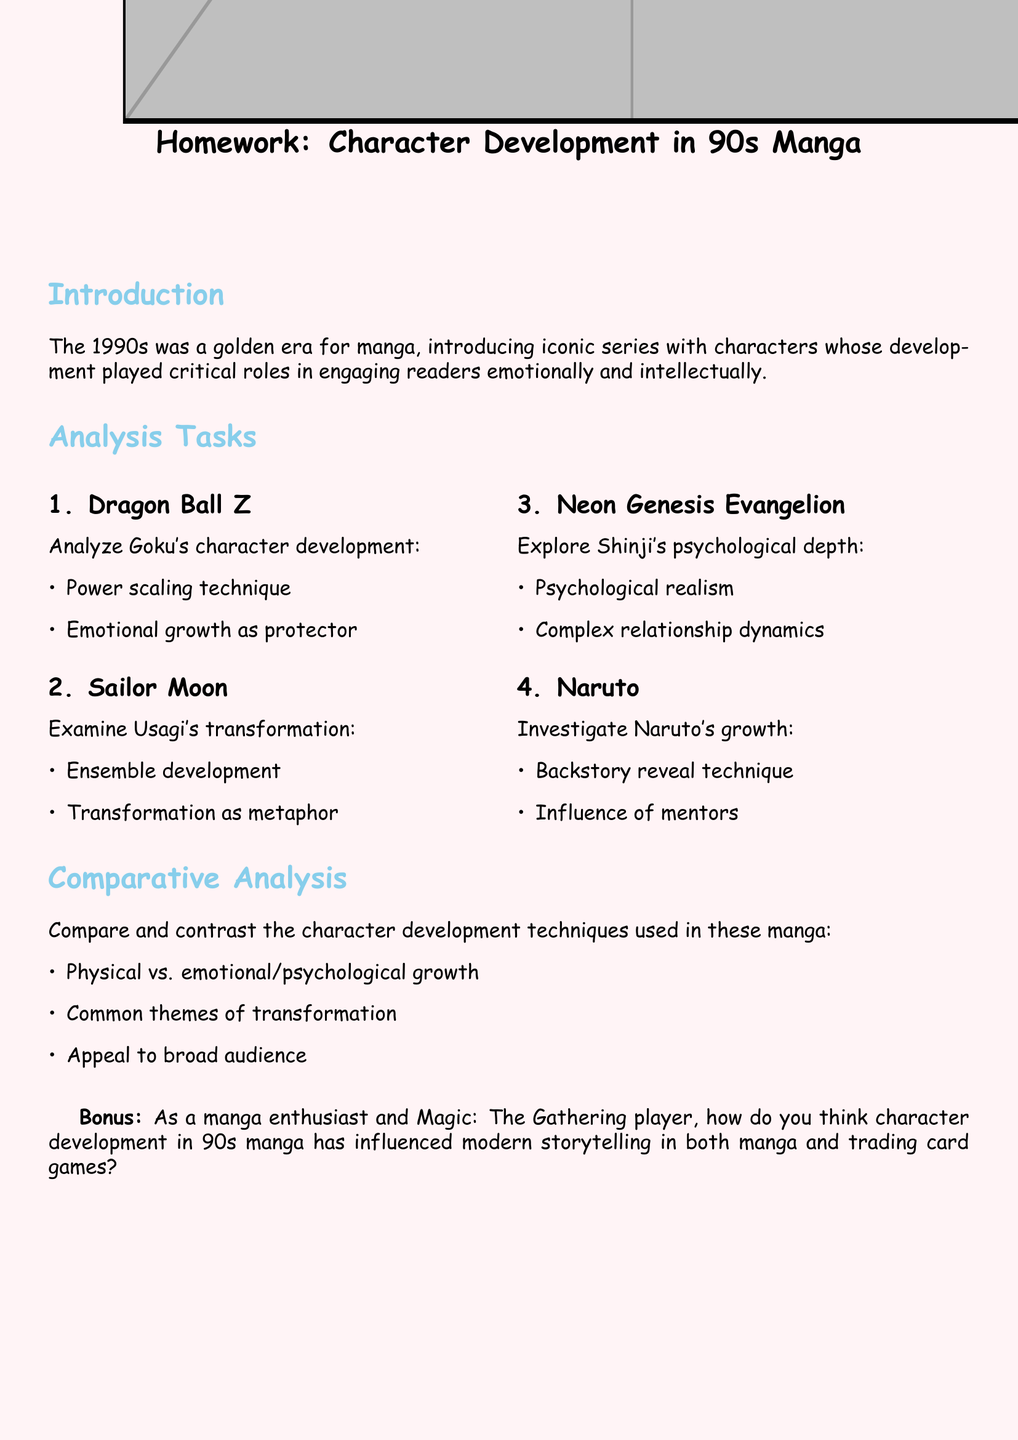What are the titles of the four manga analyzed? The document lists Dragon Ball Z, Sailor Moon, Neon Genesis Evangelion, and Naruto as the titles being analyzed.
Answer: Dragon Ball Z, Sailor Moon, Neon Genesis Evangelion, Naruto What character does the document analyze from Dragon Ball Z? The character analyzed from Dragon Ball Z is Goku.
Answer: Goku What development technique is specific to Usagi in Sailor Moon? The document mentions "ensemble development" as a technique related to Usagi's character transformation.
Answer: Ensemble development Which character's depth is explored in Neon Genesis Evangelion? The document states that Shinji's psychological depth is explored in this work.
Answer: Shinji What type of growth is investigated for Naruto? The document states that "growth" refers specifically to his backstory reveal technique.
Answer: Backstory reveal technique What theme is common across the character developments in the analyzed manga? The document indicates that “transformation” is a common theme in the character developments.
Answer: Transformation How does the document categorize character development techniques? The document categorizes them into physical vs. emotional/psychological growth.
Answer: Physical vs. emotional/psychological growth What is the bonus question topic in the document? The bonus question asks about the influence of 90s manga character development on modern storytelling in manga and trading card games.
Answer: Influence on modern storytelling What is the purpose of the document? The document serves as a homework assignment analyzing character development techniques in 90s manga.
Answer: Homework assignment 